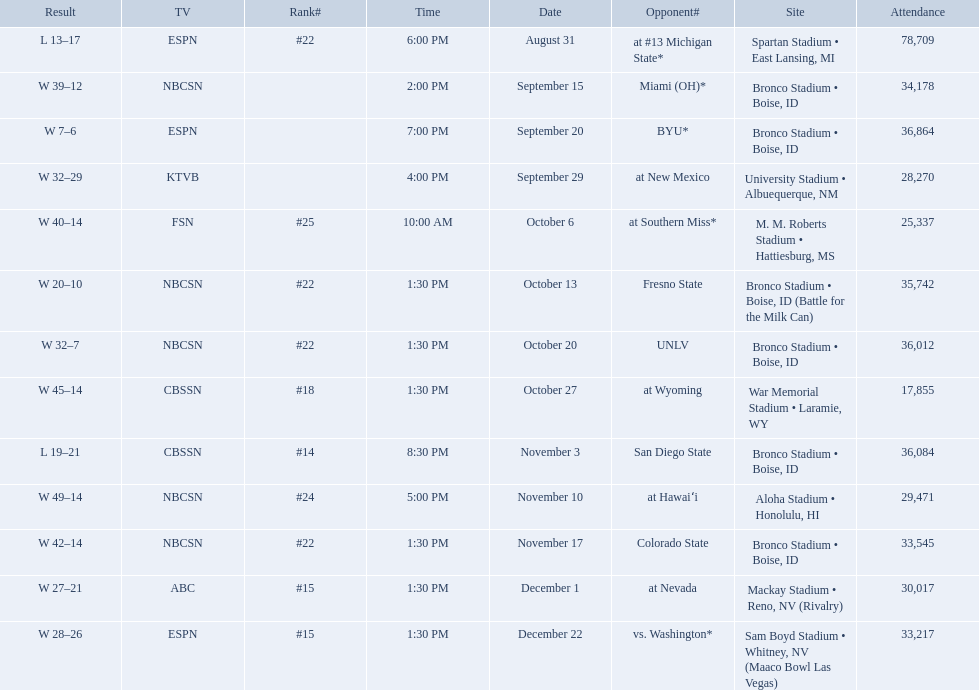What are all of the rankings? #22, , , , #25, #22, #22, #18, #14, #24, #22, #15, #15. Which of them was the best position? #14. 